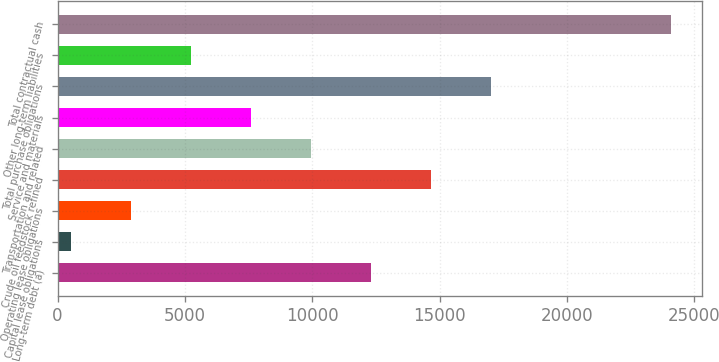<chart> <loc_0><loc_0><loc_500><loc_500><bar_chart><fcel>Long-term debt (a)<fcel>Capital lease obligations<fcel>Operating lease obligations<fcel>Crude oil feedstock refined<fcel>Transportation and related<fcel>Service and materials<fcel>Total purchase obligations<fcel>Other long-term liabilities<fcel>Total contractual cash<nl><fcel>12317<fcel>546<fcel>2900.2<fcel>14671.2<fcel>9962.8<fcel>7608.6<fcel>17025.4<fcel>5254.4<fcel>24088<nl></chart> 